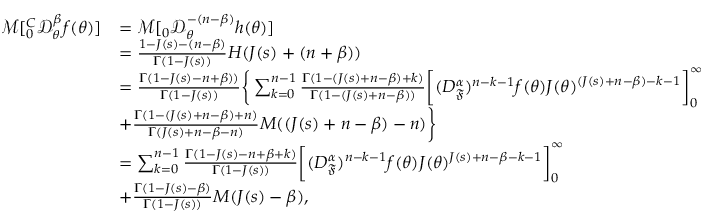Convert formula to latex. <formula><loc_0><loc_0><loc_500><loc_500>\begin{array} { r l } { \mathcal { M } [ _ { 0 } ^ { C } \mathcal { D } _ { \theta } ^ { \beta } f ( \theta ) ] } & { = \mathcal { M } [ _ { 0 } \mathcal { D } _ { \theta } ^ { - ( n - \beta ) } h ( \theta ) ] } \\ & { = \frac { 1 - J ( s ) - ( n - \beta ) } { \Gamma ( 1 - J ( s ) ) } H ( J ( s ) + ( n + \beta ) ) } \\ & { = \frac { \Gamma ( 1 - J ( s ) - n + \beta ) ) } { \Gamma ( 1 - J ( s ) ) } \left \{ \sum _ { k = 0 } ^ { n - 1 } \frac { \Gamma ( 1 - ( J ( s ) + n - \beta ) + k ) } { \Gamma ( 1 - ( J ( s ) + n - \beta ) ) } \left [ ( D _ { \mathfrak { F } } ^ { \alpha } ) ^ { n - k - 1 } f ( \theta ) J ( \theta ) ^ { ( J ( s ) + n - \beta ) - k - 1 } \right ] _ { 0 } ^ { \infty } } \\ & { + \frac { \Gamma ( 1 - ( J ( s ) + n - \beta ) + n ) } { \Gamma ( J ( s ) + n - \beta - n ) } M ( ( J ( s ) + n - \beta ) - n ) \right \} } \\ & { = \sum _ { k = 0 } ^ { n - 1 } \frac { \Gamma ( 1 - J ( s ) - n + \beta + k ) } { \Gamma ( 1 - J ( s ) ) } \left [ ( D _ { \mathfrak { F } } ^ { \alpha } ) ^ { n - k - 1 } f ( \theta ) J ( \theta ) ^ { J ( s ) + n - \beta - k - 1 } \right ] _ { 0 } ^ { \infty } } \\ & { + \frac { \Gamma ( 1 - J ( s ) - \beta ) } { \Gamma ( 1 - J ( s ) ) } M ( J ( s ) - \beta ) , } \end{array}</formula> 